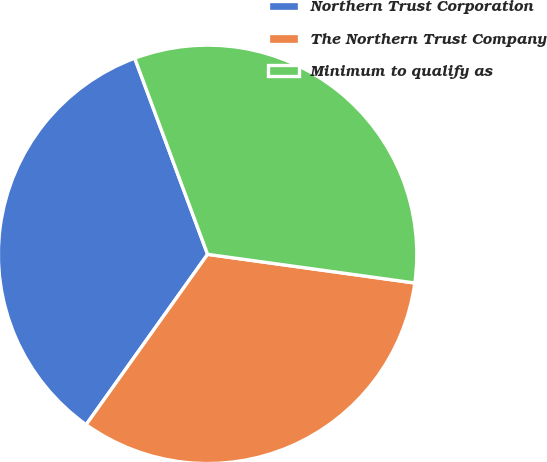Convert chart. <chart><loc_0><loc_0><loc_500><loc_500><pie_chart><fcel>Northern Trust Corporation<fcel>The Northern Trust Company<fcel>Minimum to qualify as<nl><fcel>34.48%<fcel>32.67%<fcel>32.85%<nl></chart> 